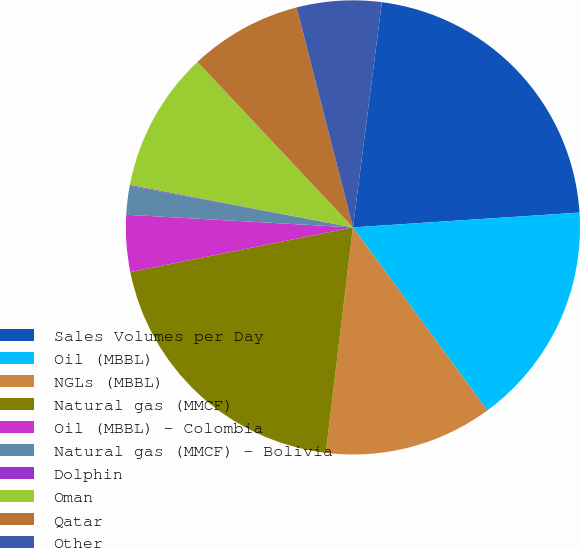<chart> <loc_0><loc_0><loc_500><loc_500><pie_chart><fcel>Sales Volumes per Day<fcel>Oil (MBBL)<fcel>NGLs (MBBL)<fcel>Natural gas (MMCF)<fcel>Oil (MBBL) - Colombia<fcel>Natural gas (MMCF) - Bolivia<fcel>Dolphin<fcel>Oman<fcel>Qatar<fcel>Other<nl><fcel>21.93%<fcel>15.96%<fcel>11.99%<fcel>19.94%<fcel>4.04%<fcel>2.05%<fcel>0.06%<fcel>10.0%<fcel>8.01%<fcel>6.02%<nl></chart> 